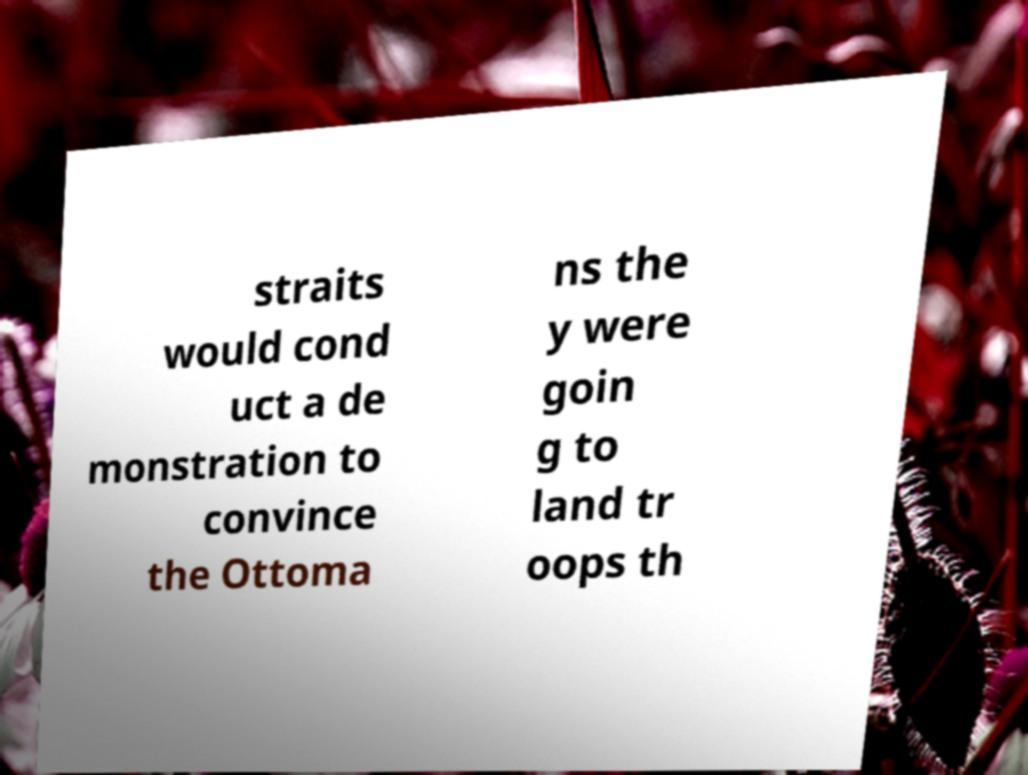I need the written content from this picture converted into text. Can you do that? straits would cond uct a de monstration to convince the Ottoma ns the y were goin g to land tr oops th 